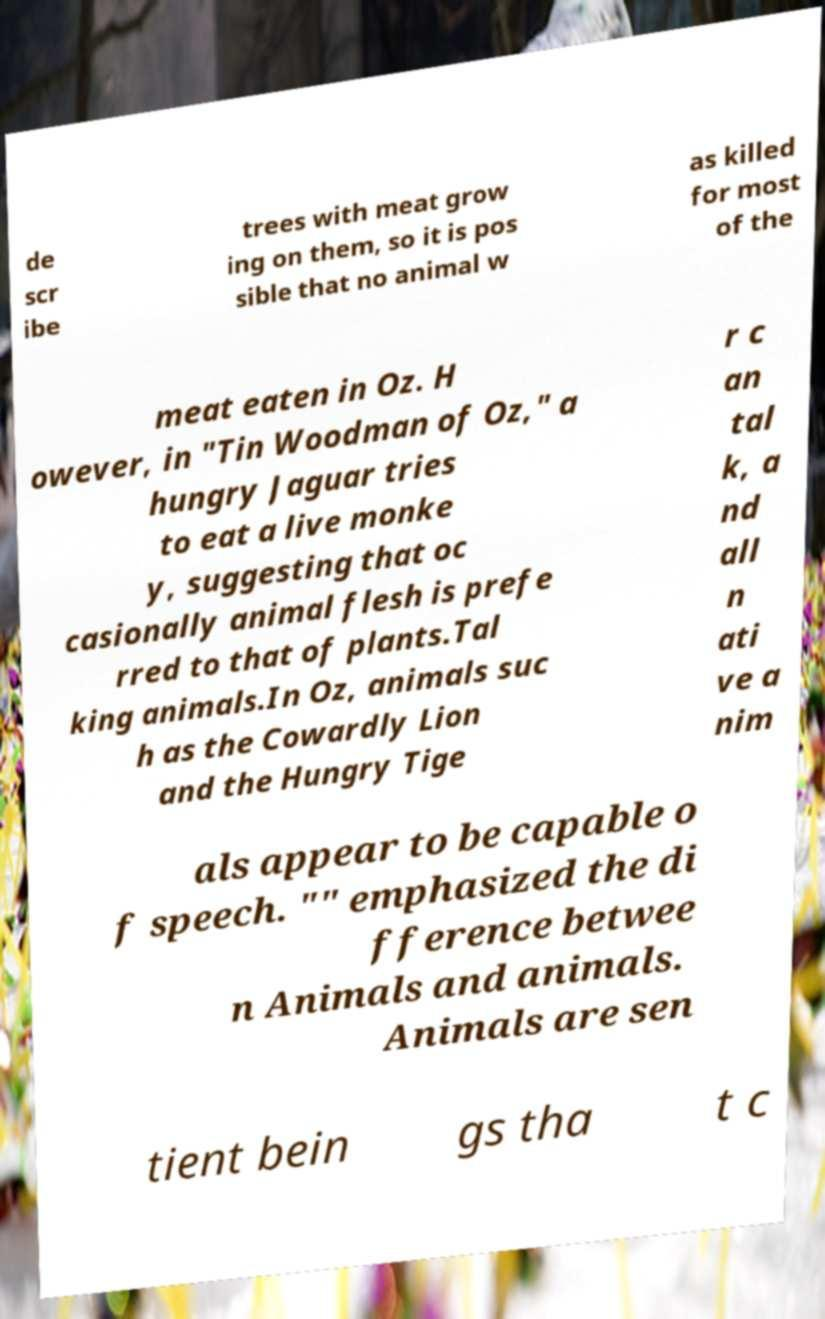Please identify and transcribe the text found in this image. de scr ibe trees with meat grow ing on them, so it is pos sible that no animal w as killed for most of the meat eaten in Oz. H owever, in "Tin Woodman of Oz," a hungry Jaguar tries to eat a live monke y, suggesting that oc casionally animal flesh is prefe rred to that of plants.Tal king animals.In Oz, animals suc h as the Cowardly Lion and the Hungry Tige r c an tal k, a nd all n ati ve a nim als appear to be capable o f speech. "" emphasized the di fference betwee n Animals and animals. Animals are sen tient bein gs tha t c 